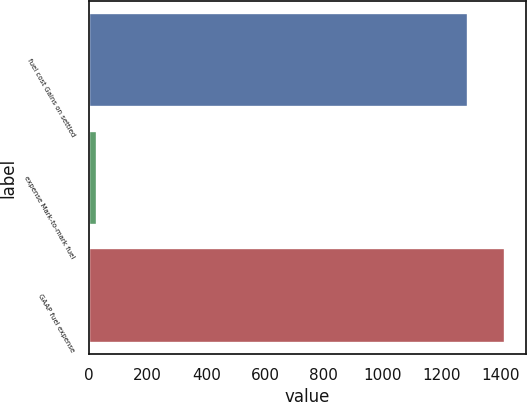Convert chart to OTSL. <chart><loc_0><loc_0><loc_500><loc_500><bar_chart><fcel>fuel cost Gains on settled<fcel>expense Mark-to-mark fuel<fcel>GAAP fuel expense<nl><fcel>1289<fcel>30<fcel>1415.8<nl></chart> 